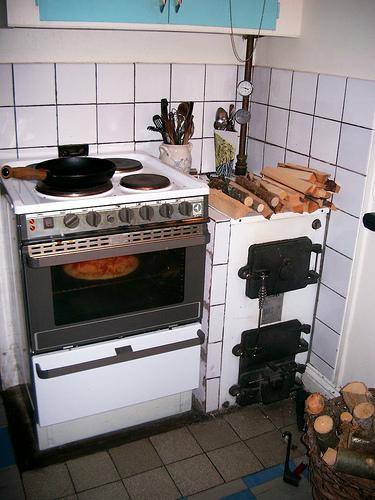How many knobs are on the oven?
Quick response, please. 6. Is something being baked?
Be succinct. Yes. Do you see firewood?
Write a very short answer. Yes. Is this kitchen sanitary?
Be succinct. Yes. Is the oven new?
Be succinct. No. What is baking in the oven?
Short answer required. Pizza. Is this stove working?
Write a very short answer. Yes. What heat source is being used here?
Short answer required. Oven. How many pizzas are on the racks?
Give a very brief answer. 1. 